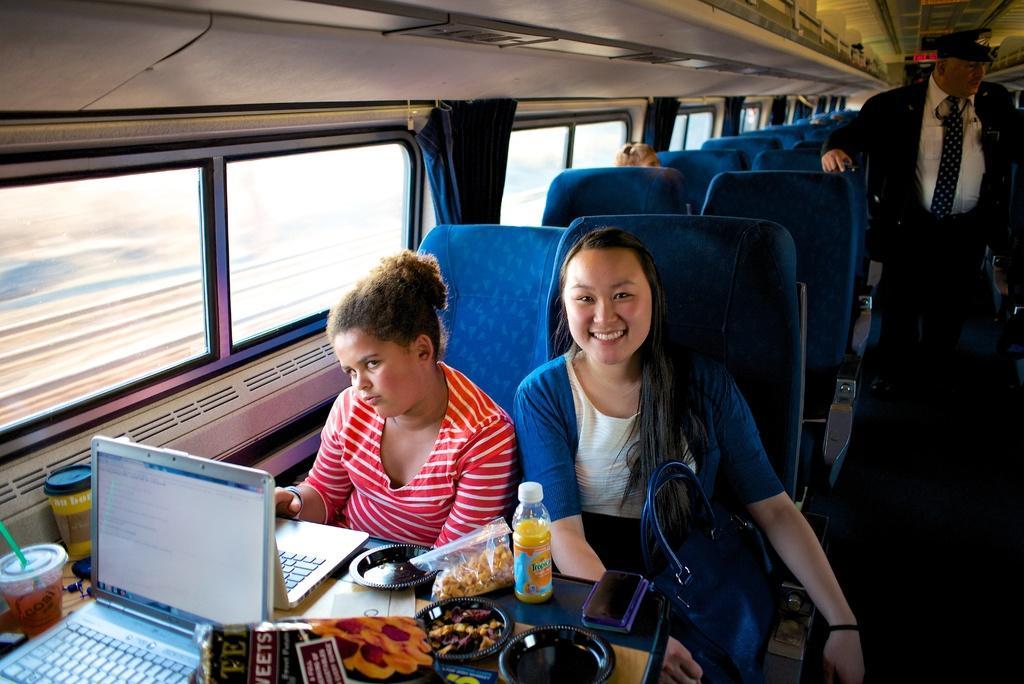Can you describe this image briefly? This picture is taken inside a vehicle. Right side a person is standing. He is wearing a cap. Left side two women are sitting on the seats. Before them there is a table having two laptops, few packets, cups, plates are on it. At the right side of the image there is a bag beside the woman. Middle of the image a person is sitting on the seat. Left side there are few windows having curtain. 